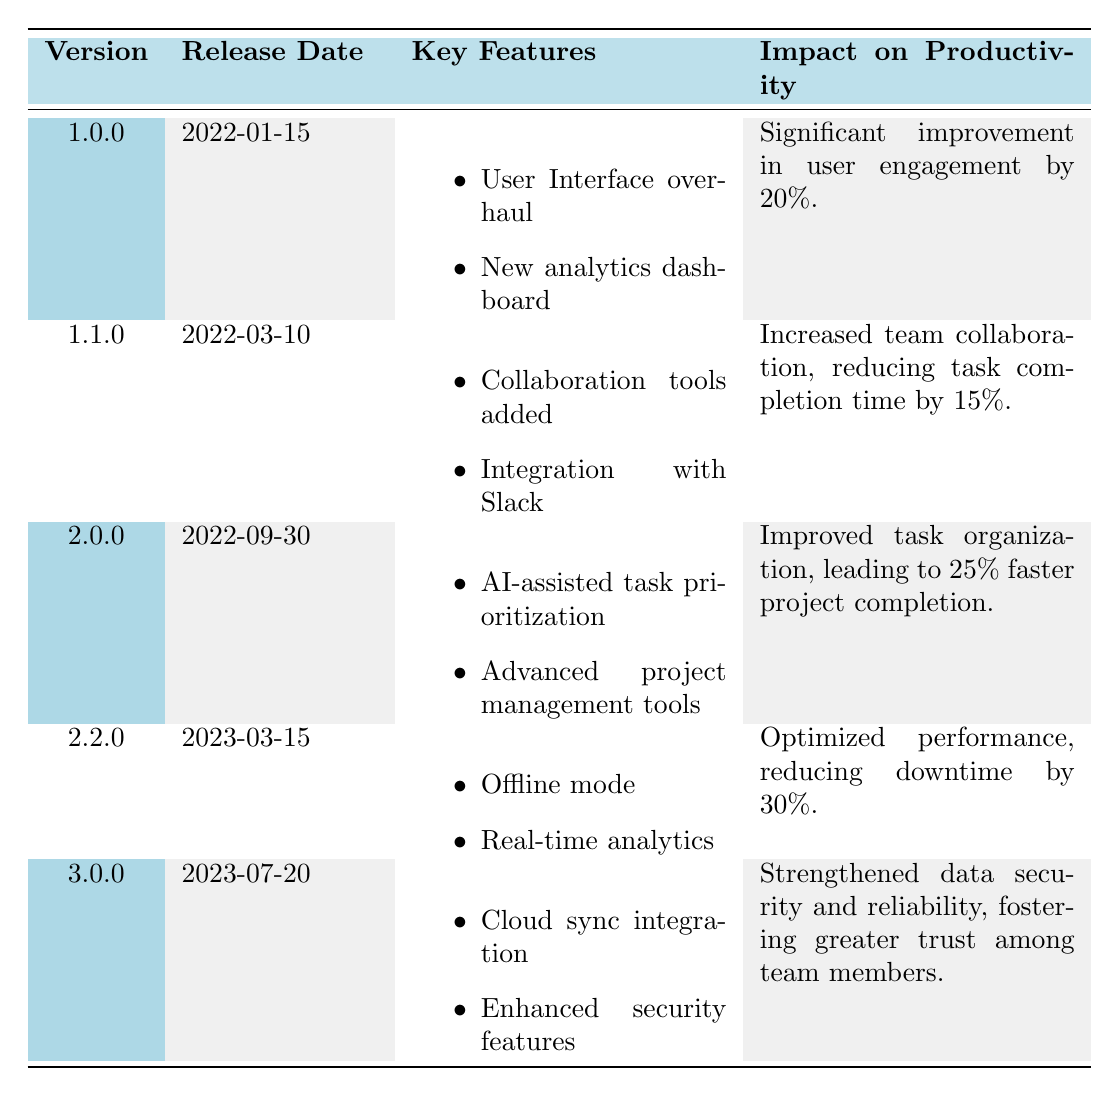What is the release date of version 1.2.0? By looking at the table, we can find the release dates associated with each version. Version 1.2.0 has the release date listed as 2022-06-20.
Answer: 2022-06-20 Which version had the greatest impact on productivity in terms of percentage? The table contains the impact percentages for each version. Comparing these, version 2.0.0 has the highest impact, which is a 25% faster project completion.
Answer: 2.0.0 Did version 2.1.0 introduce any new collaboration tools? The features for version 2.1.0 include customizable dashboards and role-based access permissions, but there is no mention of collaboration tools. Therefore, it did not introduce any.
Answer: No What is the average percentage improvement in productivity across all versions? The percentages from the impact on productivity are 20%, 15%, 10%, 25%, 12%, 30%, and the total percentage is 112%. There are 6 versions, thus the average is 112 / 6 = 18.67%.
Answer: 18.67% Which release introduced offline mode? The table specifies the features for each version. Offline mode was introduced in version 2.2.0.
Answer: 2.2.0 What was the impact of version 1.0.0 on user engagement? The impact on productivity for version 1.0.0 is stated as a "significant improvement in user engagement by 20%." This directly answers the question.
Answer: 20% Which versions released after March 2022 had enhancements in security or reliability? Versions released after March 2022 are 2.2.0 and 3.0.0. Only version 3.0.0 mentions enhanced security features, thereby enhancing reliability.
Answer: 3.0.0 How many software updates mentioned resolving specific user issues in bug fixes? By reviewing the bug fix sections across all versions, 5 out of 6 updates mentioned resolving particular user issues, making it clear that user issues were a focus.
Answer: 5 Which version's features most contributed to team collaboration? The features of version 1.1.0 include "Collaboration tools added" and "Integration with Slack," making it the version with the most impact on collaboration.
Answer: 1.1.0 What was the overall trend in productivity improvement from the versions released from January 2022 to March 2023? Looking at the impact on productivity, there's a general trend of increasing improvement: from 20% to 25% in version 2.0.0, suggesting that software updates gradually enhanced productivity.
Answer: General improvement 